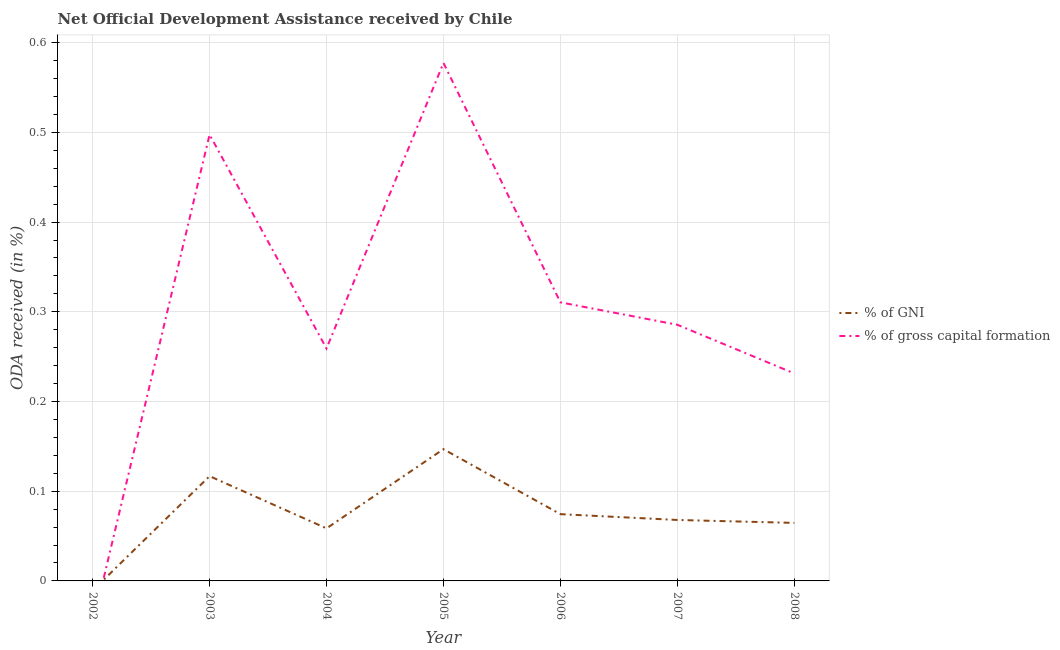What is the oda received as percentage of gni in 2006?
Give a very brief answer. 0.07. Across all years, what is the maximum oda received as percentage of gross capital formation?
Your answer should be compact. 0.58. In which year was the oda received as percentage of gross capital formation maximum?
Offer a very short reply. 2005. What is the total oda received as percentage of gni in the graph?
Offer a very short reply. 0.53. What is the difference between the oda received as percentage of gross capital formation in 2007 and that in 2008?
Offer a terse response. 0.05. What is the difference between the oda received as percentage of gross capital formation in 2007 and the oda received as percentage of gni in 2008?
Give a very brief answer. 0.22. What is the average oda received as percentage of gross capital formation per year?
Provide a succinct answer. 0.31. In the year 2006, what is the difference between the oda received as percentage of gni and oda received as percentage of gross capital formation?
Ensure brevity in your answer.  -0.24. In how many years, is the oda received as percentage of gni greater than 0.18 %?
Keep it short and to the point. 0. What is the ratio of the oda received as percentage of gross capital formation in 2005 to that in 2007?
Your answer should be compact. 2.02. Is the difference between the oda received as percentage of gni in 2003 and 2006 greater than the difference between the oda received as percentage of gross capital formation in 2003 and 2006?
Give a very brief answer. No. What is the difference between the highest and the second highest oda received as percentage of gross capital formation?
Keep it short and to the point. 0.08. What is the difference between the highest and the lowest oda received as percentage of gross capital formation?
Your answer should be compact. 0.58. Is the sum of the oda received as percentage of gni in 2005 and 2008 greater than the maximum oda received as percentage of gross capital formation across all years?
Your response must be concise. No. Does the oda received as percentage of gni monotonically increase over the years?
Your response must be concise. No. Is the oda received as percentage of gross capital formation strictly less than the oda received as percentage of gni over the years?
Make the answer very short. No. What is the difference between two consecutive major ticks on the Y-axis?
Your answer should be compact. 0.1. Does the graph contain any zero values?
Make the answer very short. Yes. Does the graph contain grids?
Your answer should be very brief. Yes. Where does the legend appear in the graph?
Give a very brief answer. Center right. What is the title of the graph?
Your response must be concise. Net Official Development Assistance received by Chile. Does "Diarrhea" appear as one of the legend labels in the graph?
Your answer should be compact. No. What is the label or title of the X-axis?
Provide a short and direct response. Year. What is the label or title of the Y-axis?
Provide a succinct answer. ODA received (in %). What is the ODA received (in %) of % of gross capital formation in 2002?
Provide a short and direct response. 0. What is the ODA received (in %) in % of GNI in 2003?
Provide a short and direct response. 0.12. What is the ODA received (in %) in % of gross capital formation in 2003?
Ensure brevity in your answer.  0.5. What is the ODA received (in %) in % of GNI in 2004?
Your answer should be compact. 0.06. What is the ODA received (in %) of % of gross capital formation in 2004?
Provide a short and direct response. 0.26. What is the ODA received (in %) of % of GNI in 2005?
Provide a succinct answer. 0.15. What is the ODA received (in %) of % of gross capital formation in 2005?
Make the answer very short. 0.58. What is the ODA received (in %) in % of GNI in 2006?
Ensure brevity in your answer.  0.07. What is the ODA received (in %) in % of gross capital formation in 2006?
Provide a short and direct response. 0.31. What is the ODA received (in %) in % of GNI in 2007?
Offer a terse response. 0.07. What is the ODA received (in %) in % of gross capital formation in 2007?
Keep it short and to the point. 0.29. What is the ODA received (in %) in % of GNI in 2008?
Keep it short and to the point. 0.06. What is the ODA received (in %) in % of gross capital formation in 2008?
Your answer should be compact. 0.23. Across all years, what is the maximum ODA received (in %) in % of GNI?
Ensure brevity in your answer.  0.15. Across all years, what is the maximum ODA received (in %) in % of gross capital formation?
Keep it short and to the point. 0.58. Across all years, what is the minimum ODA received (in %) of % of GNI?
Give a very brief answer. 0. Across all years, what is the minimum ODA received (in %) in % of gross capital formation?
Your answer should be compact. 0. What is the total ODA received (in %) in % of GNI in the graph?
Provide a short and direct response. 0.53. What is the total ODA received (in %) in % of gross capital formation in the graph?
Ensure brevity in your answer.  2.16. What is the difference between the ODA received (in %) of % of GNI in 2003 and that in 2004?
Give a very brief answer. 0.06. What is the difference between the ODA received (in %) in % of gross capital formation in 2003 and that in 2004?
Provide a succinct answer. 0.24. What is the difference between the ODA received (in %) in % of GNI in 2003 and that in 2005?
Offer a very short reply. -0.03. What is the difference between the ODA received (in %) of % of gross capital formation in 2003 and that in 2005?
Make the answer very short. -0.08. What is the difference between the ODA received (in %) of % of GNI in 2003 and that in 2006?
Your response must be concise. 0.04. What is the difference between the ODA received (in %) of % of gross capital formation in 2003 and that in 2006?
Provide a succinct answer. 0.19. What is the difference between the ODA received (in %) of % of GNI in 2003 and that in 2007?
Give a very brief answer. 0.05. What is the difference between the ODA received (in %) of % of gross capital formation in 2003 and that in 2007?
Provide a succinct answer. 0.21. What is the difference between the ODA received (in %) of % of GNI in 2003 and that in 2008?
Give a very brief answer. 0.05. What is the difference between the ODA received (in %) of % of gross capital formation in 2003 and that in 2008?
Keep it short and to the point. 0.27. What is the difference between the ODA received (in %) of % of GNI in 2004 and that in 2005?
Keep it short and to the point. -0.09. What is the difference between the ODA received (in %) of % of gross capital formation in 2004 and that in 2005?
Keep it short and to the point. -0.32. What is the difference between the ODA received (in %) of % of GNI in 2004 and that in 2006?
Offer a terse response. -0.02. What is the difference between the ODA received (in %) in % of gross capital formation in 2004 and that in 2006?
Your answer should be compact. -0.05. What is the difference between the ODA received (in %) in % of GNI in 2004 and that in 2007?
Make the answer very short. -0.01. What is the difference between the ODA received (in %) in % of gross capital formation in 2004 and that in 2007?
Ensure brevity in your answer.  -0.03. What is the difference between the ODA received (in %) of % of GNI in 2004 and that in 2008?
Offer a terse response. -0.01. What is the difference between the ODA received (in %) of % of gross capital formation in 2004 and that in 2008?
Your answer should be compact. 0.03. What is the difference between the ODA received (in %) in % of GNI in 2005 and that in 2006?
Offer a terse response. 0.07. What is the difference between the ODA received (in %) of % of gross capital formation in 2005 and that in 2006?
Your response must be concise. 0.27. What is the difference between the ODA received (in %) in % of GNI in 2005 and that in 2007?
Provide a short and direct response. 0.08. What is the difference between the ODA received (in %) of % of gross capital formation in 2005 and that in 2007?
Ensure brevity in your answer.  0.29. What is the difference between the ODA received (in %) in % of GNI in 2005 and that in 2008?
Give a very brief answer. 0.08. What is the difference between the ODA received (in %) of % of gross capital formation in 2005 and that in 2008?
Your answer should be very brief. 0.35. What is the difference between the ODA received (in %) in % of GNI in 2006 and that in 2007?
Your answer should be very brief. 0.01. What is the difference between the ODA received (in %) of % of gross capital formation in 2006 and that in 2007?
Keep it short and to the point. 0.03. What is the difference between the ODA received (in %) of % of GNI in 2006 and that in 2008?
Offer a very short reply. 0.01. What is the difference between the ODA received (in %) of % of gross capital formation in 2006 and that in 2008?
Offer a very short reply. 0.08. What is the difference between the ODA received (in %) in % of GNI in 2007 and that in 2008?
Give a very brief answer. 0. What is the difference between the ODA received (in %) of % of gross capital formation in 2007 and that in 2008?
Offer a very short reply. 0.05. What is the difference between the ODA received (in %) of % of GNI in 2003 and the ODA received (in %) of % of gross capital formation in 2004?
Keep it short and to the point. -0.14. What is the difference between the ODA received (in %) of % of GNI in 2003 and the ODA received (in %) of % of gross capital formation in 2005?
Your answer should be very brief. -0.46. What is the difference between the ODA received (in %) in % of GNI in 2003 and the ODA received (in %) in % of gross capital formation in 2006?
Offer a very short reply. -0.19. What is the difference between the ODA received (in %) of % of GNI in 2003 and the ODA received (in %) of % of gross capital formation in 2007?
Offer a terse response. -0.17. What is the difference between the ODA received (in %) of % of GNI in 2003 and the ODA received (in %) of % of gross capital formation in 2008?
Your response must be concise. -0.11. What is the difference between the ODA received (in %) of % of GNI in 2004 and the ODA received (in %) of % of gross capital formation in 2005?
Keep it short and to the point. -0.52. What is the difference between the ODA received (in %) of % of GNI in 2004 and the ODA received (in %) of % of gross capital formation in 2006?
Keep it short and to the point. -0.25. What is the difference between the ODA received (in %) of % of GNI in 2004 and the ODA received (in %) of % of gross capital formation in 2007?
Provide a succinct answer. -0.23. What is the difference between the ODA received (in %) of % of GNI in 2004 and the ODA received (in %) of % of gross capital formation in 2008?
Ensure brevity in your answer.  -0.17. What is the difference between the ODA received (in %) in % of GNI in 2005 and the ODA received (in %) in % of gross capital formation in 2006?
Make the answer very short. -0.16. What is the difference between the ODA received (in %) of % of GNI in 2005 and the ODA received (in %) of % of gross capital formation in 2007?
Offer a very short reply. -0.14. What is the difference between the ODA received (in %) of % of GNI in 2005 and the ODA received (in %) of % of gross capital formation in 2008?
Offer a terse response. -0.08. What is the difference between the ODA received (in %) of % of GNI in 2006 and the ODA received (in %) of % of gross capital formation in 2007?
Your answer should be compact. -0.21. What is the difference between the ODA received (in %) of % of GNI in 2006 and the ODA received (in %) of % of gross capital formation in 2008?
Offer a terse response. -0.16. What is the difference between the ODA received (in %) in % of GNI in 2007 and the ODA received (in %) in % of gross capital formation in 2008?
Provide a succinct answer. -0.16. What is the average ODA received (in %) in % of GNI per year?
Offer a terse response. 0.08. What is the average ODA received (in %) of % of gross capital formation per year?
Provide a short and direct response. 0.31. In the year 2003, what is the difference between the ODA received (in %) of % of GNI and ODA received (in %) of % of gross capital formation?
Provide a short and direct response. -0.38. In the year 2004, what is the difference between the ODA received (in %) of % of GNI and ODA received (in %) of % of gross capital formation?
Ensure brevity in your answer.  -0.2. In the year 2005, what is the difference between the ODA received (in %) in % of GNI and ODA received (in %) in % of gross capital formation?
Offer a terse response. -0.43. In the year 2006, what is the difference between the ODA received (in %) of % of GNI and ODA received (in %) of % of gross capital formation?
Provide a short and direct response. -0.24. In the year 2007, what is the difference between the ODA received (in %) in % of GNI and ODA received (in %) in % of gross capital formation?
Keep it short and to the point. -0.22. In the year 2008, what is the difference between the ODA received (in %) in % of GNI and ODA received (in %) in % of gross capital formation?
Make the answer very short. -0.17. What is the ratio of the ODA received (in %) of % of GNI in 2003 to that in 2004?
Offer a terse response. 1.99. What is the ratio of the ODA received (in %) of % of gross capital formation in 2003 to that in 2004?
Your response must be concise. 1.92. What is the ratio of the ODA received (in %) of % of GNI in 2003 to that in 2005?
Provide a short and direct response. 0.8. What is the ratio of the ODA received (in %) in % of gross capital formation in 2003 to that in 2005?
Make the answer very short. 0.86. What is the ratio of the ODA received (in %) in % of GNI in 2003 to that in 2006?
Your answer should be compact. 1.57. What is the ratio of the ODA received (in %) of % of gross capital formation in 2003 to that in 2006?
Your answer should be compact. 1.6. What is the ratio of the ODA received (in %) in % of GNI in 2003 to that in 2007?
Offer a terse response. 1.72. What is the ratio of the ODA received (in %) in % of gross capital formation in 2003 to that in 2007?
Keep it short and to the point. 1.74. What is the ratio of the ODA received (in %) of % of GNI in 2003 to that in 2008?
Make the answer very short. 1.81. What is the ratio of the ODA received (in %) of % of gross capital formation in 2003 to that in 2008?
Make the answer very short. 2.15. What is the ratio of the ODA received (in %) in % of GNI in 2004 to that in 2005?
Give a very brief answer. 0.4. What is the ratio of the ODA received (in %) of % of gross capital formation in 2004 to that in 2005?
Your answer should be compact. 0.45. What is the ratio of the ODA received (in %) in % of GNI in 2004 to that in 2006?
Offer a terse response. 0.79. What is the ratio of the ODA received (in %) of % of gross capital formation in 2004 to that in 2006?
Provide a short and direct response. 0.83. What is the ratio of the ODA received (in %) of % of GNI in 2004 to that in 2007?
Offer a terse response. 0.86. What is the ratio of the ODA received (in %) of % of gross capital formation in 2004 to that in 2007?
Your response must be concise. 0.91. What is the ratio of the ODA received (in %) in % of GNI in 2004 to that in 2008?
Your response must be concise. 0.91. What is the ratio of the ODA received (in %) of % of gross capital formation in 2004 to that in 2008?
Your answer should be compact. 1.12. What is the ratio of the ODA received (in %) of % of GNI in 2005 to that in 2006?
Offer a terse response. 1.97. What is the ratio of the ODA received (in %) of % of gross capital formation in 2005 to that in 2006?
Provide a short and direct response. 1.86. What is the ratio of the ODA received (in %) of % of GNI in 2005 to that in 2007?
Your answer should be very brief. 2.16. What is the ratio of the ODA received (in %) of % of gross capital formation in 2005 to that in 2007?
Your answer should be very brief. 2.02. What is the ratio of the ODA received (in %) in % of GNI in 2005 to that in 2008?
Ensure brevity in your answer.  2.27. What is the ratio of the ODA received (in %) of % of gross capital formation in 2005 to that in 2008?
Offer a very short reply. 2.5. What is the ratio of the ODA received (in %) in % of GNI in 2006 to that in 2007?
Give a very brief answer. 1.1. What is the ratio of the ODA received (in %) in % of gross capital formation in 2006 to that in 2007?
Provide a succinct answer. 1.09. What is the ratio of the ODA received (in %) of % of GNI in 2006 to that in 2008?
Ensure brevity in your answer.  1.15. What is the ratio of the ODA received (in %) in % of gross capital formation in 2006 to that in 2008?
Offer a very short reply. 1.34. What is the ratio of the ODA received (in %) of % of GNI in 2007 to that in 2008?
Provide a short and direct response. 1.05. What is the ratio of the ODA received (in %) of % of gross capital formation in 2007 to that in 2008?
Your answer should be compact. 1.23. What is the difference between the highest and the second highest ODA received (in %) of % of GNI?
Offer a terse response. 0.03. What is the difference between the highest and the second highest ODA received (in %) in % of gross capital formation?
Ensure brevity in your answer.  0.08. What is the difference between the highest and the lowest ODA received (in %) of % of GNI?
Offer a terse response. 0.15. What is the difference between the highest and the lowest ODA received (in %) of % of gross capital formation?
Give a very brief answer. 0.58. 